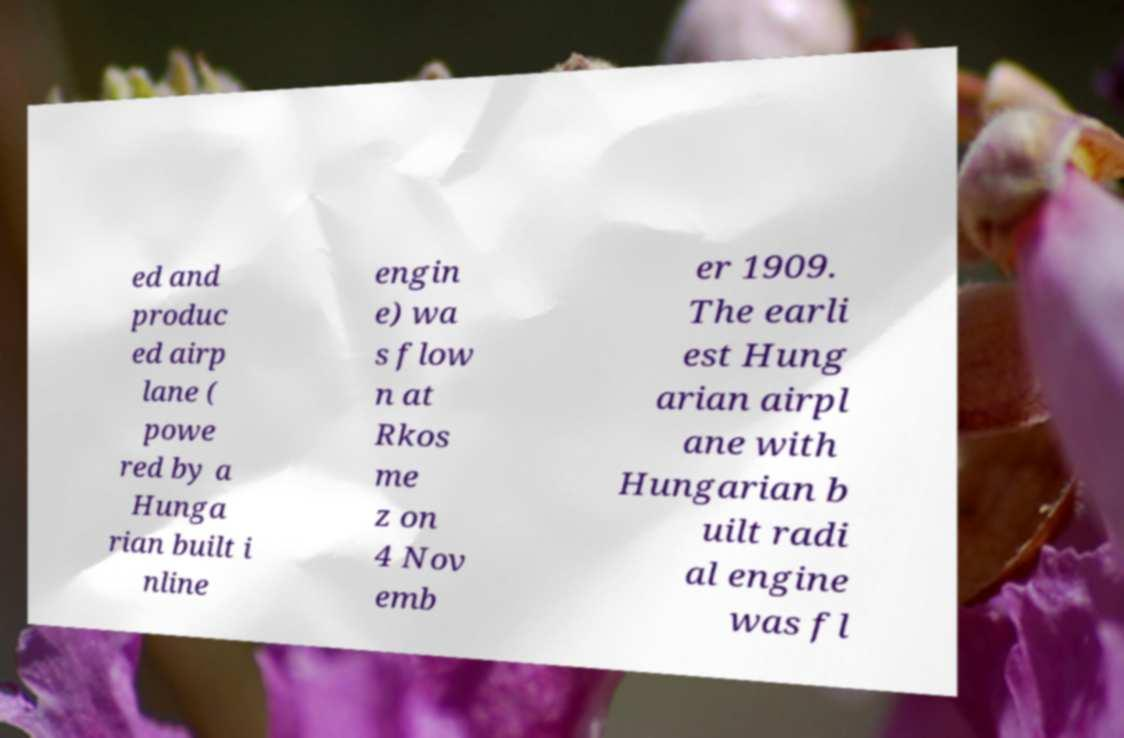Could you extract and type out the text from this image? ed and produc ed airp lane ( powe red by a Hunga rian built i nline engin e) wa s flow n at Rkos me z on 4 Nov emb er 1909. The earli est Hung arian airpl ane with Hungarian b uilt radi al engine was fl 